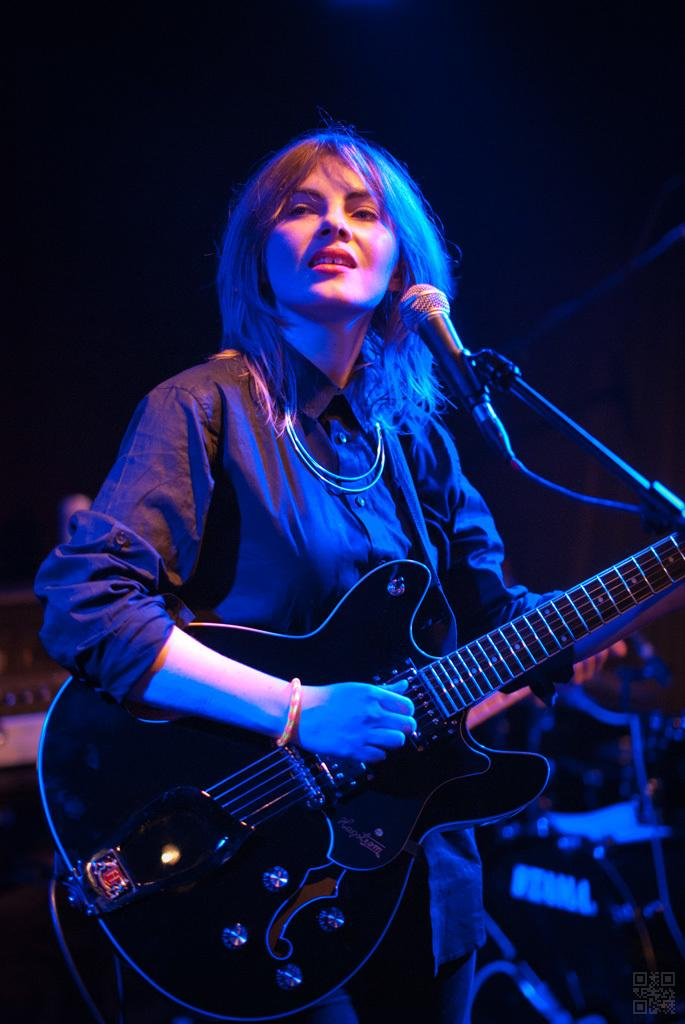Who is the main subject in the image? There is a woman in the image. What is the woman holding in the image? The woman is holding a guitar. What is in front of the woman? There is a microphone and a stand in front of the woman. What is the woman doing in the image? The woman is singing. What type of rifle can be seen leaning against the stand in the image? There is no rifle present in the image; the woman is holding a guitar and there is a microphone and stand in front of her. 